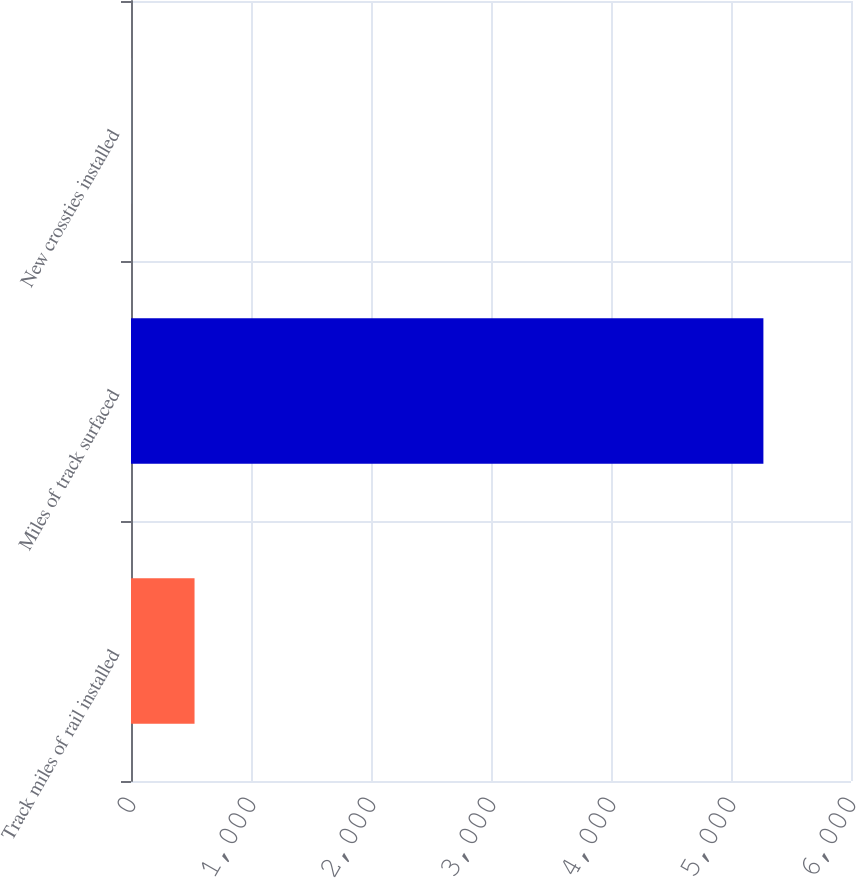Convert chart to OTSL. <chart><loc_0><loc_0><loc_500><loc_500><bar_chart><fcel>Track miles of rail installed<fcel>Miles of track surfaced<fcel>New crossties installed<nl><fcel>529.52<fcel>5270<fcel>2.8<nl></chart> 